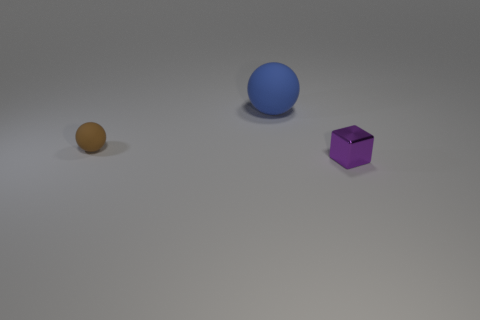Add 1 blue metal things. How many objects exist? 4 Subtract all balls. How many objects are left? 1 Subtract all metal things. Subtract all small brown spheres. How many objects are left? 1 Add 2 small brown balls. How many small brown balls are left? 3 Add 3 blue matte spheres. How many blue matte spheres exist? 4 Subtract 0 red cylinders. How many objects are left? 3 